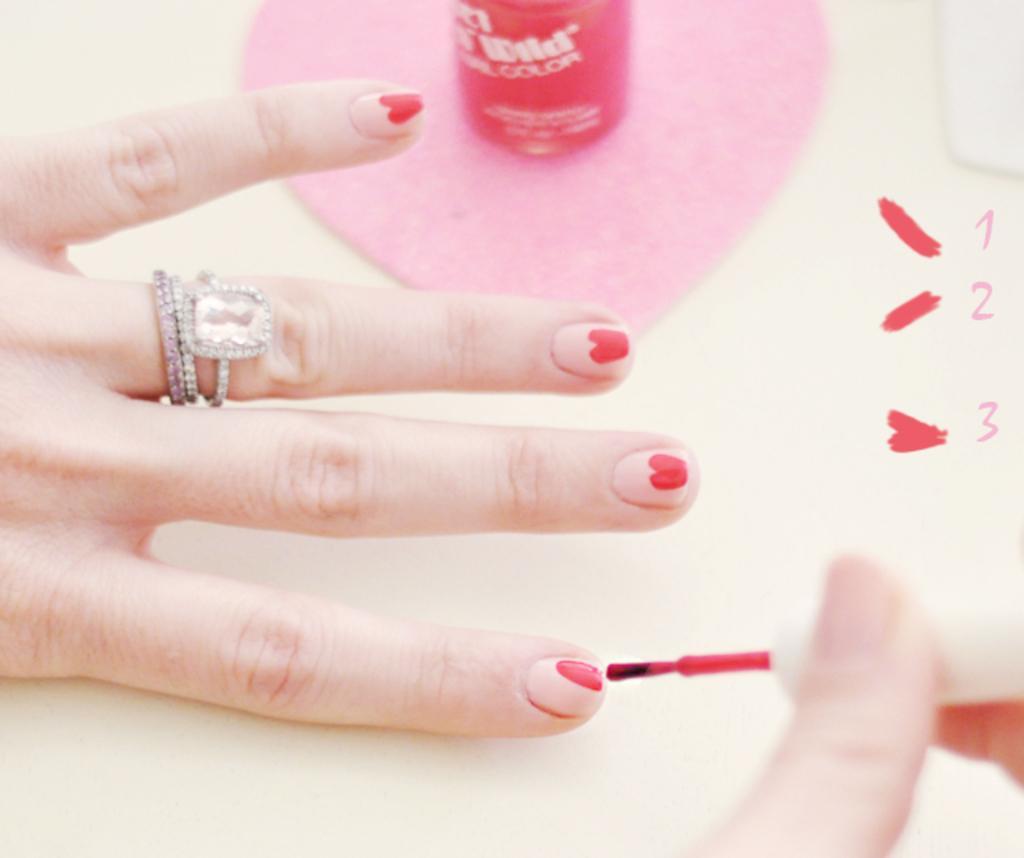In one or two sentences, can you explain what this image depicts? In this image I can see human hands. I can see few rings to the finger. I can see the cream colored surface and on it I can see a pink colored cloth. On the cloth I can see the red colored nail polish bottle. 